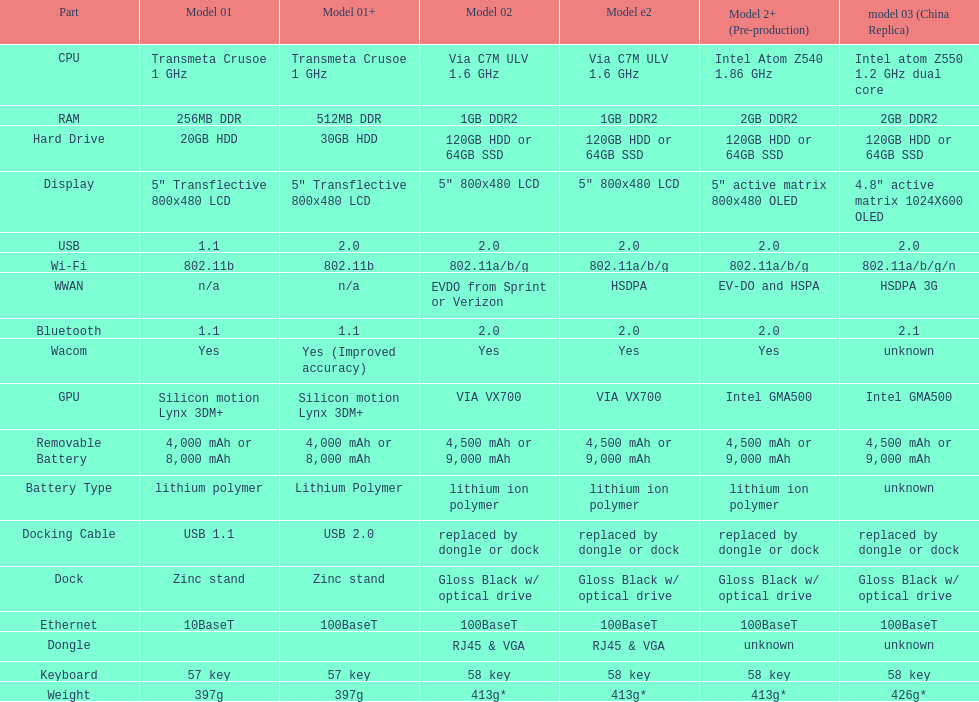The model 2 and the model 2e have what type of cpu? Via C7M ULV 1.6 GHz. 